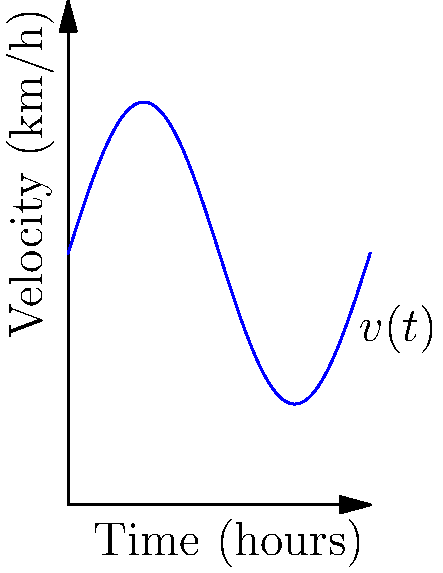A cyclist's velocity (in km/h) over a 6-hour period is represented by the function $v(t) = 5 + 3\sin(\frac{\pi t}{3})$, where $t$ is time in hours. Using the velocity-time graph provided, calculate the total distance traveled by the cyclist during this period. How does this relate to the reduction of air pollution compared to motorized transportation? To find the total distance traveled, we need to calculate the area under the velocity-time curve. This can be done using definite integration:

1) The distance traveled is given by the integral:
   $$D = \int_{0}^{6} v(t) dt = \int_{0}^{6} (5 + 3\sin(\frac{\pi t}{3})) dt$$

2) Let's break this into two parts:
   $$\int_{0}^{6} 5 dt + \int_{0}^{6} 3\sin(\frac{\pi t}{3}) dt$$

3) For the first part:
   $$\int_{0}^{6} 5 dt = 5t |_{0}^{6} = 30$$

4) For the second part, we use u-substitution:
   Let $u = \frac{\pi t}{3}$, then $du = \frac{\pi}{3} dt$ or $dt = \frac{3}{\pi} du$
   When $t = 0$, $u = 0$; when $t = 6$, $u = 2\pi$

   $$\int_{0}^{6} 3\sin(\frac{\pi t}{3}) dt = 3 \cdot \frac{3}{\pi} \int_{0}^{2\pi} \sin(u) du = \frac{9}{\pi} [-\cos(u)]_{0}^{2\pi} = 0$$

5) Adding the results:
   $$D = 30 + 0 = 30 \text{ km}$$

Regarding air pollution, this cyclist traveled 30 km without emitting any pollutants, unlike motorized vehicles. If we assume an average car emits about 120 grams of CO2 per km, this cycling trip potentially avoided 3.6 kg of CO2 emissions (30 km * 120 g/km), contributing to better air quality and reduced environmental impact.
Answer: 30 km 